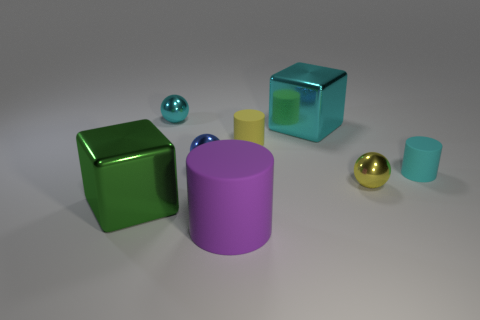Add 1 matte objects. How many objects exist? 9 Subtract all spheres. How many objects are left? 5 Add 1 blue metal objects. How many blue metal objects exist? 2 Subtract 1 purple cylinders. How many objects are left? 7 Subtract all small yellow matte objects. Subtract all small metallic things. How many objects are left? 4 Add 2 blue metallic spheres. How many blue metallic spheres are left? 3 